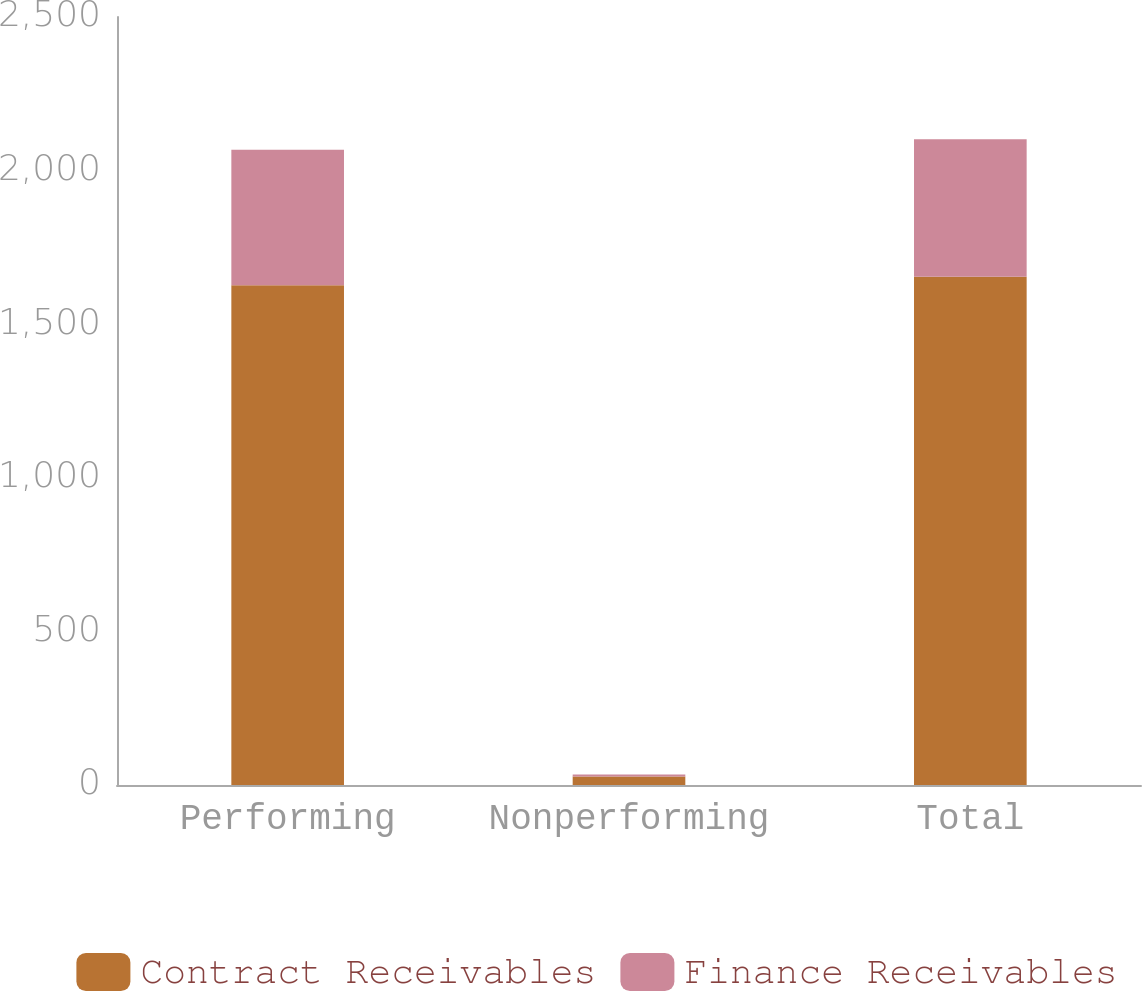Convert chart. <chart><loc_0><loc_0><loc_500><loc_500><stacked_bar_chart><ecel><fcel>Performing<fcel>Nonperforming<fcel>Total<nl><fcel>Contract Receivables<fcel>1626.4<fcel>27.9<fcel>1654.3<nl><fcel>Finance Receivables<fcel>441.5<fcel>6<fcel>447.5<nl></chart> 